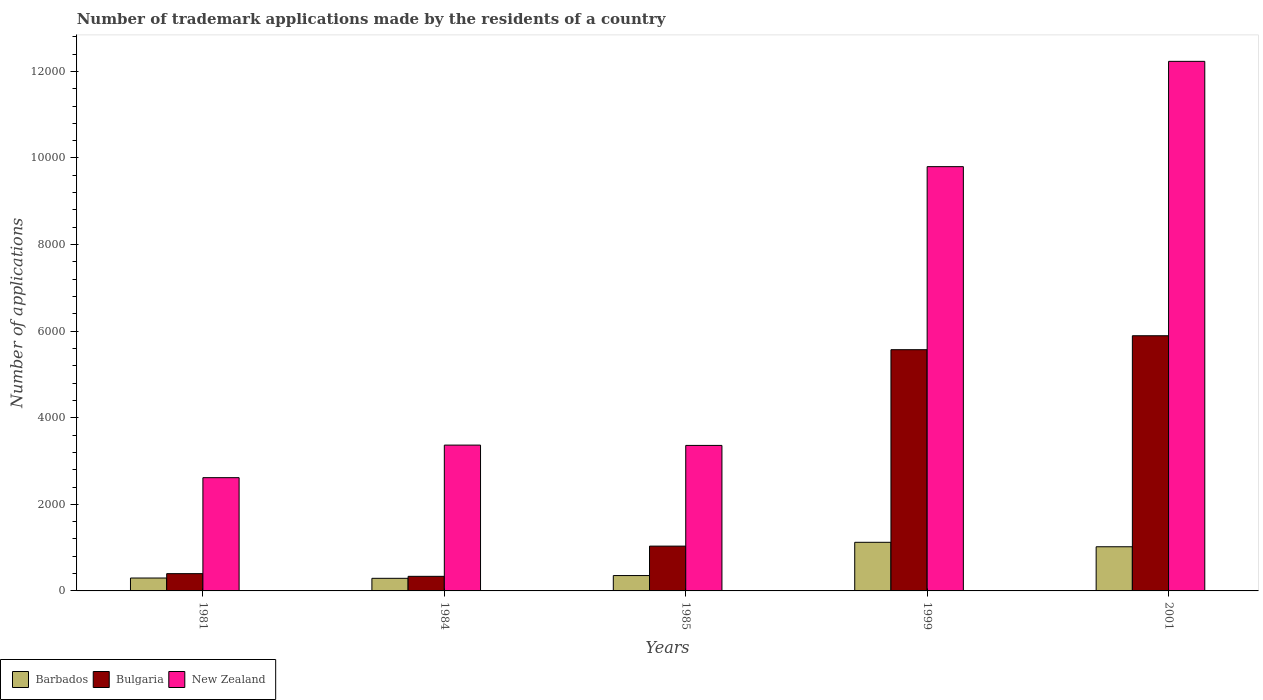How many groups of bars are there?
Ensure brevity in your answer.  5. Are the number of bars per tick equal to the number of legend labels?
Ensure brevity in your answer.  Yes. Are the number of bars on each tick of the X-axis equal?
Give a very brief answer. Yes. How many bars are there on the 2nd tick from the left?
Offer a very short reply. 3. How many bars are there on the 3rd tick from the right?
Ensure brevity in your answer.  3. What is the label of the 4th group of bars from the left?
Ensure brevity in your answer.  1999. In how many cases, is the number of bars for a given year not equal to the number of legend labels?
Offer a very short reply. 0. What is the number of trademark applications made by the residents in Bulgaria in 1999?
Make the answer very short. 5572. Across all years, what is the maximum number of trademark applications made by the residents in Barbados?
Your answer should be compact. 1123. Across all years, what is the minimum number of trademark applications made by the residents in Barbados?
Make the answer very short. 291. In which year was the number of trademark applications made by the residents in Bulgaria minimum?
Make the answer very short. 1984. What is the total number of trademark applications made by the residents in New Zealand in the graph?
Keep it short and to the point. 3.14e+04. What is the difference between the number of trademark applications made by the residents in Barbados in 1981 and that in 1999?
Your answer should be very brief. -825. What is the difference between the number of trademark applications made by the residents in Barbados in 1981 and the number of trademark applications made by the residents in Bulgaria in 1984?
Ensure brevity in your answer.  -39. What is the average number of trademark applications made by the residents in New Zealand per year?
Offer a terse response. 6275.4. In the year 1999, what is the difference between the number of trademark applications made by the residents in Barbados and number of trademark applications made by the residents in Bulgaria?
Provide a short and direct response. -4449. In how many years, is the number of trademark applications made by the residents in Bulgaria greater than 11200?
Your answer should be compact. 0. What is the ratio of the number of trademark applications made by the residents in Bulgaria in 1981 to that in 1984?
Offer a terse response. 1.18. Is the number of trademark applications made by the residents in Bulgaria in 1985 less than that in 2001?
Make the answer very short. Yes. Is the difference between the number of trademark applications made by the residents in Barbados in 1999 and 2001 greater than the difference between the number of trademark applications made by the residents in Bulgaria in 1999 and 2001?
Your answer should be very brief. Yes. What is the difference between the highest and the second highest number of trademark applications made by the residents in Bulgaria?
Keep it short and to the point. 322. What is the difference between the highest and the lowest number of trademark applications made by the residents in Barbados?
Keep it short and to the point. 832. What does the 3rd bar from the left in 1984 represents?
Make the answer very short. New Zealand. What does the 3rd bar from the right in 1984 represents?
Provide a succinct answer. Barbados. How many years are there in the graph?
Your response must be concise. 5. What is the difference between two consecutive major ticks on the Y-axis?
Offer a very short reply. 2000. Does the graph contain any zero values?
Offer a very short reply. No. Where does the legend appear in the graph?
Give a very brief answer. Bottom left. What is the title of the graph?
Your response must be concise. Number of trademark applications made by the residents of a country. Does "Pacific island small states" appear as one of the legend labels in the graph?
Provide a succinct answer. No. What is the label or title of the Y-axis?
Offer a terse response. Number of applications. What is the Number of applications in Barbados in 1981?
Provide a short and direct response. 298. What is the Number of applications of Bulgaria in 1981?
Offer a terse response. 399. What is the Number of applications in New Zealand in 1981?
Your answer should be very brief. 2616. What is the Number of applications of Barbados in 1984?
Your response must be concise. 291. What is the Number of applications of Bulgaria in 1984?
Provide a short and direct response. 337. What is the Number of applications in New Zealand in 1984?
Your answer should be compact. 3368. What is the Number of applications of Barbados in 1985?
Provide a short and direct response. 355. What is the Number of applications of Bulgaria in 1985?
Give a very brief answer. 1035. What is the Number of applications in New Zealand in 1985?
Provide a short and direct response. 3361. What is the Number of applications of Barbados in 1999?
Your answer should be compact. 1123. What is the Number of applications in Bulgaria in 1999?
Offer a terse response. 5572. What is the Number of applications of New Zealand in 1999?
Give a very brief answer. 9800. What is the Number of applications in Barbados in 2001?
Your response must be concise. 1020. What is the Number of applications of Bulgaria in 2001?
Make the answer very short. 5894. What is the Number of applications of New Zealand in 2001?
Make the answer very short. 1.22e+04. Across all years, what is the maximum Number of applications of Barbados?
Give a very brief answer. 1123. Across all years, what is the maximum Number of applications in Bulgaria?
Offer a very short reply. 5894. Across all years, what is the maximum Number of applications in New Zealand?
Offer a terse response. 1.22e+04. Across all years, what is the minimum Number of applications in Barbados?
Your response must be concise. 291. Across all years, what is the minimum Number of applications in Bulgaria?
Your answer should be compact. 337. Across all years, what is the minimum Number of applications of New Zealand?
Offer a very short reply. 2616. What is the total Number of applications in Barbados in the graph?
Provide a succinct answer. 3087. What is the total Number of applications in Bulgaria in the graph?
Provide a short and direct response. 1.32e+04. What is the total Number of applications in New Zealand in the graph?
Your response must be concise. 3.14e+04. What is the difference between the Number of applications of Barbados in 1981 and that in 1984?
Offer a very short reply. 7. What is the difference between the Number of applications of New Zealand in 1981 and that in 1984?
Ensure brevity in your answer.  -752. What is the difference between the Number of applications in Barbados in 1981 and that in 1985?
Keep it short and to the point. -57. What is the difference between the Number of applications of Bulgaria in 1981 and that in 1985?
Provide a short and direct response. -636. What is the difference between the Number of applications in New Zealand in 1981 and that in 1985?
Give a very brief answer. -745. What is the difference between the Number of applications of Barbados in 1981 and that in 1999?
Provide a short and direct response. -825. What is the difference between the Number of applications of Bulgaria in 1981 and that in 1999?
Ensure brevity in your answer.  -5173. What is the difference between the Number of applications of New Zealand in 1981 and that in 1999?
Provide a succinct answer. -7184. What is the difference between the Number of applications in Barbados in 1981 and that in 2001?
Ensure brevity in your answer.  -722. What is the difference between the Number of applications in Bulgaria in 1981 and that in 2001?
Your response must be concise. -5495. What is the difference between the Number of applications in New Zealand in 1981 and that in 2001?
Make the answer very short. -9616. What is the difference between the Number of applications of Barbados in 1984 and that in 1985?
Your answer should be compact. -64. What is the difference between the Number of applications in Bulgaria in 1984 and that in 1985?
Your response must be concise. -698. What is the difference between the Number of applications of New Zealand in 1984 and that in 1985?
Provide a short and direct response. 7. What is the difference between the Number of applications of Barbados in 1984 and that in 1999?
Provide a short and direct response. -832. What is the difference between the Number of applications in Bulgaria in 1984 and that in 1999?
Ensure brevity in your answer.  -5235. What is the difference between the Number of applications of New Zealand in 1984 and that in 1999?
Keep it short and to the point. -6432. What is the difference between the Number of applications in Barbados in 1984 and that in 2001?
Your answer should be compact. -729. What is the difference between the Number of applications in Bulgaria in 1984 and that in 2001?
Make the answer very short. -5557. What is the difference between the Number of applications in New Zealand in 1984 and that in 2001?
Provide a short and direct response. -8864. What is the difference between the Number of applications of Barbados in 1985 and that in 1999?
Provide a short and direct response. -768. What is the difference between the Number of applications in Bulgaria in 1985 and that in 1999?
Your response must be concise. -4537. What is the difference between the Number of applications of New Zealand in 1985 and that in 1999?
Your answer should be compact. -6439. What is the difference between the Number of applications in Barbados in 1985 and that in 2001?
Your answer should be very brief. -665. What is the difference between the Number of applications in Bulgaria in 1985 and that in 2001?
Provide a short and direct response. -4859. What is the difference between the Number of applications of New Zealand in 1985 and that in 2001?
Your answer should be compact. -8871. What is the difference between the Number of applications of Barbados in 1999 and that in 2001?
Offer a very short reply. 103. What is the difference between the Number of applications of Bulgaria in 1999 and that in 2001?
Offer a terse response. -322. What is the difference between the Number of applications in New Zealand in 1999 and that in 2001?
Offer a very short reply. -2432. What is the difference between the Number of applications in Barbados in 1981 and the Number of applications in Bulgaria in 1984?
Offer a very short reply. -39. What is the difference between the Number of applications in Barbados in 1981 and the Number of applications in New Zealand in 1984?
Your response must be concise. -3070. What is the difference between the Number of applications of Bulgaria in 1981 and the Number of applications of New Zealand in 1984?
Provide a succinct answer. -2969. What is the difference between the Number of applications in Barbados in 1981 and the Number of applications in Bulgaria in 1985?
Offer a terse response. -737. What is the difference between the Number of applications in Barbados in 1981 and the Number of applications in New Zealand in 1985?
Keep it short and to the point. -3063. What is the difference between the Number of applications of Bulgaria in 1981 and the Number of applications of New Zealand in 1985?
Provide a short and direct response. -2962. What is the difference between the Number of applications of Barbados in 1981 and the Number of applications of Bulgaria in 1999?
Make the answer very short. -5274. What is the difference between the Number of applications in Barbados in 1981 and the Number of applications in New Zealand in 1999?
Make the answer very short. -9502. What is the difference between the Number of applications in Bulgaria in 1981 and the Number of applications in New Zealand in 1999?
Offer a terse response. -9401. What is the difference between the Number of applications in Barbados in 1981 and the Number of applications in Bulgaria in 2001?
Your answer should be very brief. -5596. What is the difference between the Number of applications in Barbados in 1981 and the Number of applications in New Zealand in 2001?
Keep it short and to the point. -1.19e+04. What is the difference between the Number of applications of Bulgaria in 1981 and the Number of applications of New Zealand in 2001?
Keep it short and to the point. -1.18e+04. What is the difference between the Number of applications of Barbados in 1984 and the Number of applications of Bulgaria in 1985?
Your answer should be very brief. -744. What is the difference between the Number of applications of Barbados in 1984 and the Number of applications of New Zealand in 1985?
Your answer should be compact. -3070. What is the difference between the Number of applications of Bulgaria in 1984 and the Number of applications of New Zealand in 1985?
Make the answer very short. -3024. What is the difference between the Number of applications in Barbados in 1984 and the Number of applications in Bulgaria in 1999?
Ensure brevity in your answer.  -5281. What is the difference between the Number of applications in Barbados in 1984 and the Number of applications in New Zealand in 1999?
Provide a short and direct response. -9509. What is the difference between the Number of applications of Bulgaria in 1984 and the Number of applications of New Zealand in 1999?
Provide a short and direct response. -9463. What is the difference between the Number of applications of Barbados in 1984 and the Number of applications of Bulgaria in 2001?
Keep it short and to the point. -5603. What is the difference between the Number of applications of Barbados in 1984 and the Number of applications of New Zealand in 2001?
Your answer should be compact. -1.19e+04. What is the difference between the Number of applications in Bulgaria in 1984 and the Number of applications in New Zealand in 2001?
Your response must be concise. -1.19e+04. What is the difference between the Number of applications in Barbados in 1985 and the Number of applications in Bulgaria in 1999?
Make the answer very short. -5217. What is the difference between the Number of applications in Barbados in 1985 and the Number of applications in New Zealand in 1999?
Ensure brevity in your answer.  -9445. What is the difference between the Number of applications in Bulgaria in 1985 and the Number of applications in New Zealand in 1999?
Give a very brief answer. -8765. What is the difference between the Number of applications of Barbados in 1985 and the Number of applications of Bulgaria in 2001?
Keep it short and to the point. -5539. What is the difference between the Number of applications in Barbados in 1985 and the Number of applications in New Zealand in 2001?
Offer a very short reply. -1.19e+04. What is the difference between the Number of applications of Bulgaria in 1985 and the Number of applications of New Zealand in 2001?
Offer a very short reply. -1.12e+04. What is the difference between the Number of applications of Barbados in 1999 and the Number of applications of Bulgaria in 2001?
Give a very brief answer. -4771. What is the difference between the Number of applications of Barbados in 1999 and the Number of applications of New Zealand in 2001?
Keep it short and to the point. -1.11e+04. What is the difference between the Number of applications of Bulgaria in 1999 and the Number of applications of New Zealand in 2001?
Keep it short and to the point. -6660. What is the average Number of applications of Barbados per year?
Provide a short and direct response. 617.4. What is the average Number of applications of Bulgaria per year?
Ensure brevity in your answer.  2647.4. What is the average Number of applications of New Zealand per year?
Offer a very short reply. 6275.4. In the year 1981, what is the difference between the Number of applications in Barbados and Number of applications in Bulgaria?
Offer a very short reply. -101. In the year 1981, what is the difference between the Number of applications of Barbados and Number of applications of New Zealand?
Provide a short and direct response. -2318. In the year 1981, what is the difference between the Number of applications of Bulgaria and Number of applications of New Zealand?
Make the answer very short. -2217. In the year 1984, what is the difference between the Number of applications of Barbados and Number of applications of Bulgaria?
Make the answer very short. -46. In the year 1984, what is the difference between the Number of applications of Barbados and Number of applications of New Zealand?
Offer a terse response. -3077. In the year 1984, what is the difference between the Number of applications of Bulgaria and Number of applications of New Zealand?
Provide a succinct answer. -3031. In the year 1985, what is the difference between the Number of applications of Barbados and Number of applications of Bulgaria?
Give a very brief answer. -680. In the year 1985, what is the difference between the Number of applications of Barbados and Number of applications of New Zealand?
Provide a succinct answer. -3006. In the year 1985, what is the difference between the Number of applications in Bulgaria and Number of applications in New Zealand?
Provide a short and direct response. -2326. In the year 1999, what is the difference between the Number of applications of Barbados and Number of applications of Bulgaria?
Ensure brevity in your answer.  -4449. In the year 1999, what is the difference between the Number of applications of Barbados and Number of applications of New Zealand?
Your response must be concise. -8677. In the year 1999, what is the difference between the Number of applications of Bulgaria and Number of applications of New Zealand?
Offer a terse response. -4228. In the year 2001, what is the difference between the Number of applications of Barbados and Number of applications of Bulgaria?
Your answer should be compact. -4874. In the year 2001, what is the difference between the Number of applications of Barbados and Number of applications of New Zealand?
Provide a short and direct response. -1.12e+04. In the year 2001, what is the difference between the Number of applications of Bulgaria and Number of applications of New Zealand?
Ensure brevity in your answer.  -6338. What is the ratio of the Number of applications of Barbados in 1981 to that in 1984?
Your answer should be very brief. 1.02. What is the ratio of the Number of applications in Bulgaria in 1981 to that in 1984?
Offer a very short reply. 1.18. What is the ratio of the Number of applications in New Zealand in 1981 to that in 1984?
Keep it short and to the point. 0.78. What is the ratio of the Number of applications of Barbados in 1981 to that in 1985?
Your response must be concise. 0.84. What is the ratio of the Number of applications of Bulgaria in 1981 to that in 1985?
Ensure brevity in your answer.  0.39. What is the ratio of the Number of applications of New Zealand in 1981 to that in 1985?
Provide a succinct answer. 0.78. What is the ratio of the Number of applications in Barbados in 1981 to that in 1999?
Your answer should be compact. 0.27. What is the ratio of the Number of applications of Bulgaria in 1981 to that in 1999?
Give a very brief answer. 0.07. What is the ratio of the Number of applications of New Zealand in 1981 to that in 1999?
Your answer should be compact. 0.27. What is the ratio of the Number of applications in Barbados in 1981 to that in 2001?
Offer a very short reply. 0.29. What is the ratio of the Number of applications in Bulgaria in 1981 to that in 2001?
Make the answer very short. 0.07. What is the ratio of the Number of applications of New Zealand in 1981 to that in 2001?
Make the answer very short. 0.21. What is the ratio of the Number of applications of Barbados in 1984 to that in 1985?
Offer a terse response. 0.82. What is the ratio of the Number of applications of Bulgaria in 1984 to that in 1985?
Your answer should be compact. 0.33. What is the ratio of the Number of applications in Barbados in 1984 to that in 1999?
Provide a short and direct response. 0.26. What is the ratio of the Number of applications of Bulgaria in 1984 to that in 1999?
Provide a succinct answer. 0.06. What is the ratio of the Number of applications in New Zealand in 1984 to that in 1999?
Ensure brevity in your answer.  0.34. What is the ratio of the Number of applications of Barbados in 1984 to that in 2001?
Ensure brevity in your answer.  0.29. What is the ratio of the Number of applications in Bulgaria in 1984 to that in 2001?
Offer a terse response. 0.06. What is the ratio of the Number of applications in New Zealand in 1984 to that in 2001?
Your answer should be compact. 0.28. What is the ratio of the Number of applications in Barbados in 1985 to that in 1999?
Provide a short and direct response. 0.32. What is the ratio of the Number of applications of Bulgaria in 1985 to that in 1999?
Make the answer very short. 0.19. What is the ratio of the Number of applications of New Zealand in 1985 to that in 1999?
Your answer should be compact. 0.34. What is the ratio of the Number of applications in Barbados in 1985 to that in 2001?
Offer a terse response. 0.35. What is the ratio of the Number of applications of Bulgaria in 1985 to that in 2001?
Your response must be concise. 0.18. What is the ratio of the Number of applications of New Zealand in 1985 to that in 2001?
Provide a short and direct response. 0.27. What is the ratio of the Number of applications of Barbados in 1999 to that in 2001?
Make the answer very short. 1.1. What is the ratio of the Number of applications of Bulgaria in 1999 to that in 2001?
Provide a short and direct response. 0.95. What is the ratio of the Number of applications in New Zealand in 1999 to that in 2001?
Provide a succinct answer. 0.8. What is the difference between the highest and the second highest Number of applications in Barbados?
Provide a short and direct response. 103. What is the difference between the highest and the second highest Number of applications of Bulgaria?
Offer a very short reply. 322. What is the difference between the highest and the second highest Number of applications in New Zealand?
Give a very brief answer. 2432. What is the difference between the highest and the lowest Number of applications of Barbados?
Keep it short and to the point. 832. What is the difference between the highest and the lowest Number of applications of Bulgaria?
Make the answer very short. 5557. What is the difference between the highest and the lowest Number of applications in New Zealand?
Provide a short and direct response. 9616. 